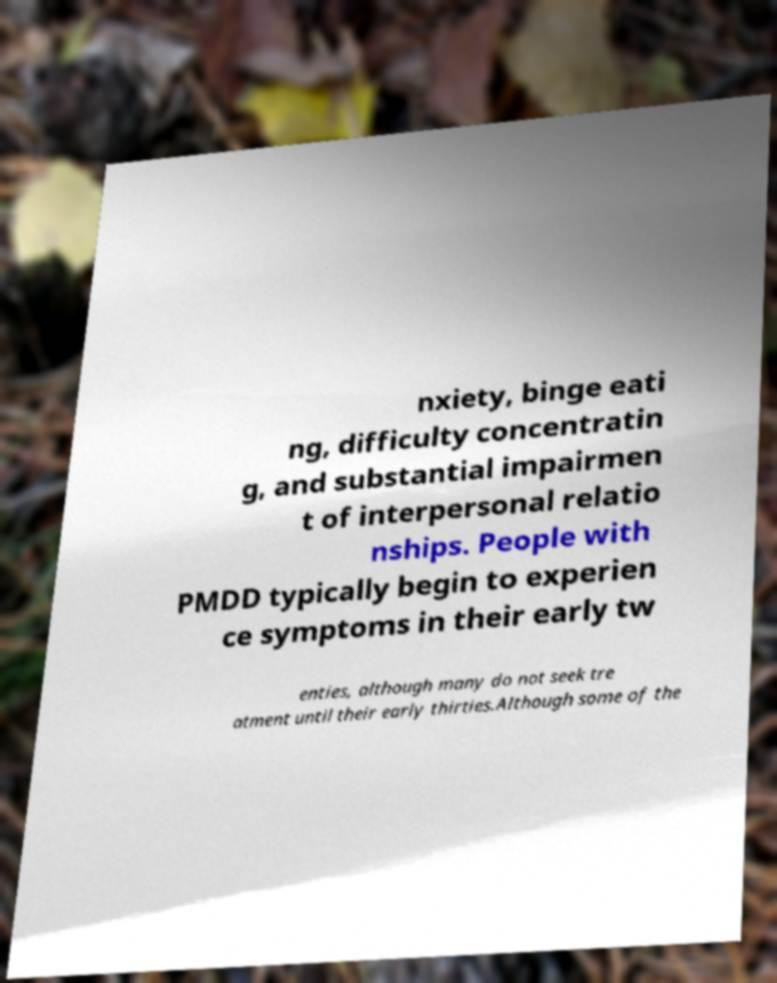Could you assist in decoding the text presented in this image and type it out clearly? nxiety, binge eati ng, difficulty concentratin g, and substantial impairmen t of interpersonal relatio nships. People with PMDD typically begin to experien ce symptoms in their early tw enties, although many do not seek tre atment until their early thirties.Although some of the 